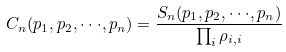Convert formula to latex. <formula><loc_0><loc_0><loc_500><loc_500>C _ { n } ( p _ { 1 } , p _ { 2 } , \cdot \cdot \cdot , p _ { n } ) = \frac { S _ { n } ( p _ { 1 } , p _ { 2 } , \cdot \cdot \cdot , p _ { n } ) } { \prod _ { i } \rho _ { i , i } }</formula> 